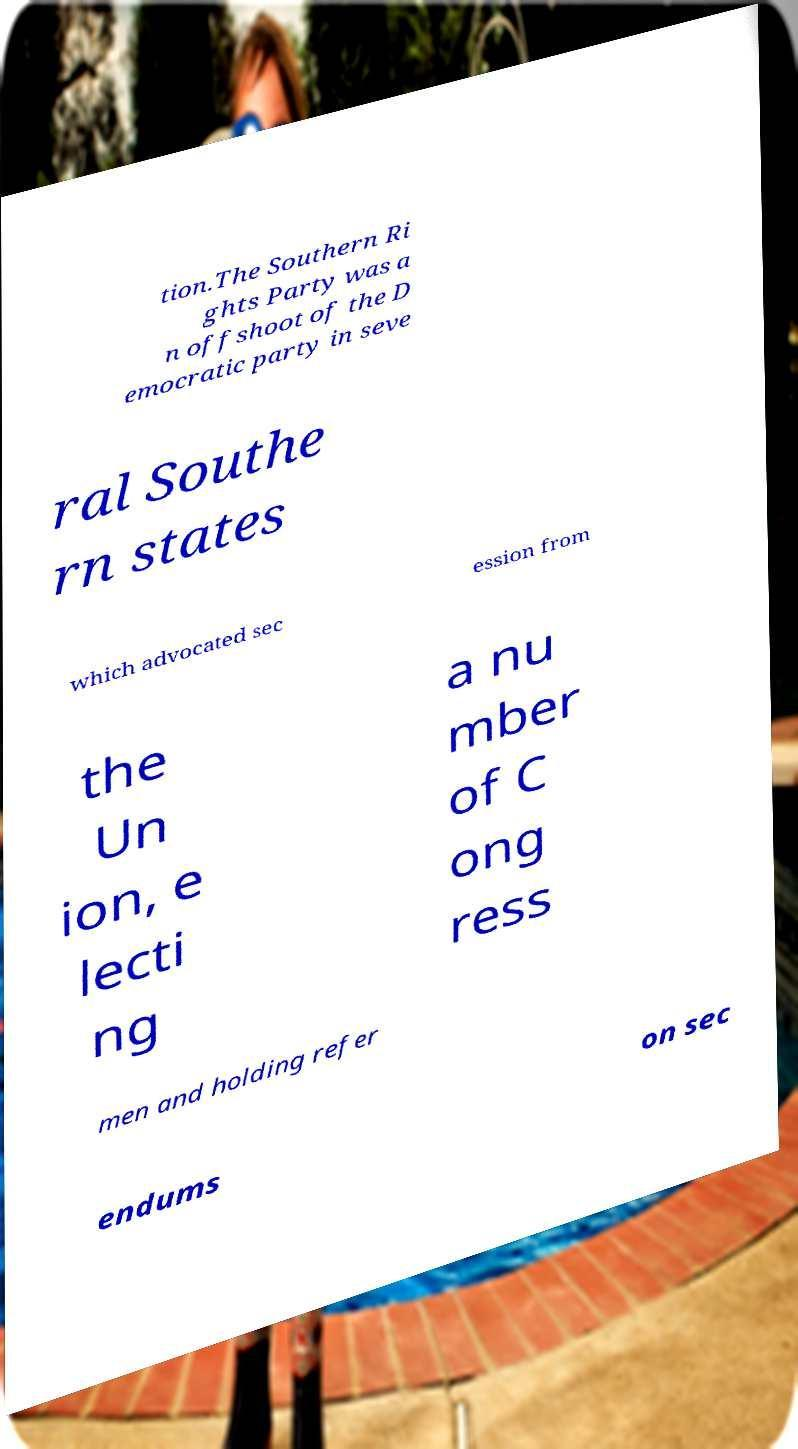Can you read and provide the text displayed in the image?This photo seems to have some interesting text. Can you extract and type it out for me? tion.The Southern Ri ghts Party was a n offshoot of the D emocratic party in seve ral Southe rn states which advocated sec ession from the Un ion, e lecti ng a nu mber of C ong ress men and holding refer endums on sec 